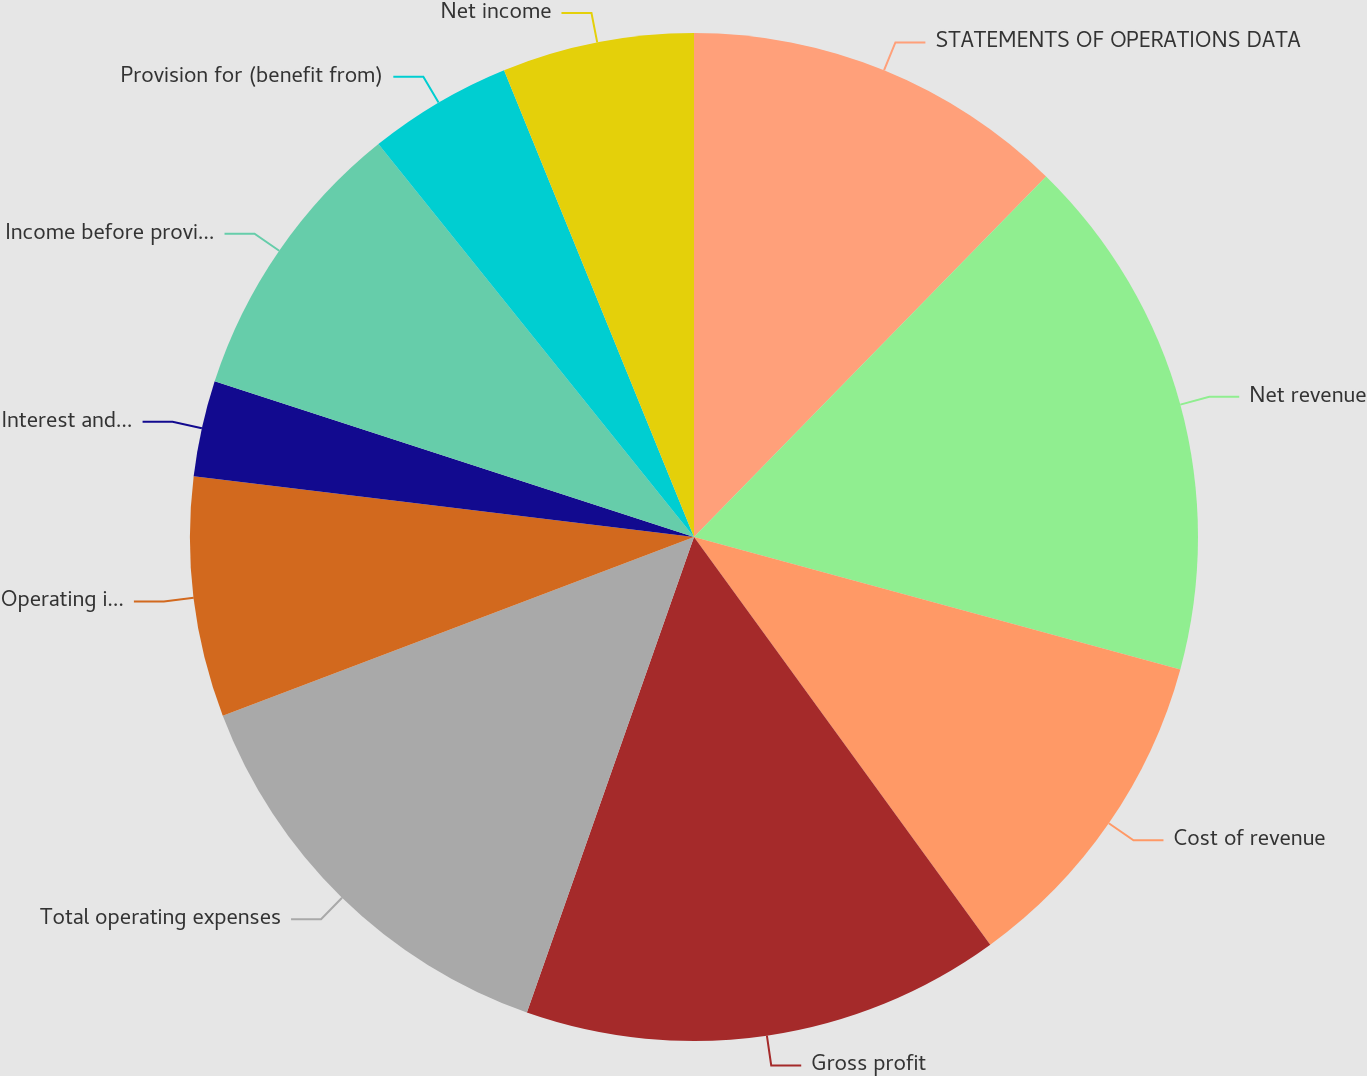Convert chart to OTSL. <chart><loc_0><loc_0><loc_500><loc_500><pie_chart><fcel>STATEMENTS OF OPERATIONS DATA<fcel>Net revenue<fcel>Cost of revenue<fcel>Gross profit<fcel>Total operating expenses<fcel>Operating income<fcel>Interest and other income<fcel>Income before provision for<fcel>Provision for (benefit from)<fcel>Net income<nl><fcel>12.31%<fcel>16.92%<fcel>10.77%<fcel>15.38%<fcel>13.85%<fcel>7.69%<fcel>3.08%<fcel>9.23%<fcel>4.62%<fcel>6.15%<nl></chart> 